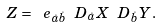Convert formula to latex. <formula><loc_0><loc_0><loc_500><loc_500>Z = \ e _ { \dot { a } \dot { b } } \ D _ { \dot { a } } X \ D _ { \dot { b } } Y .</formula> 